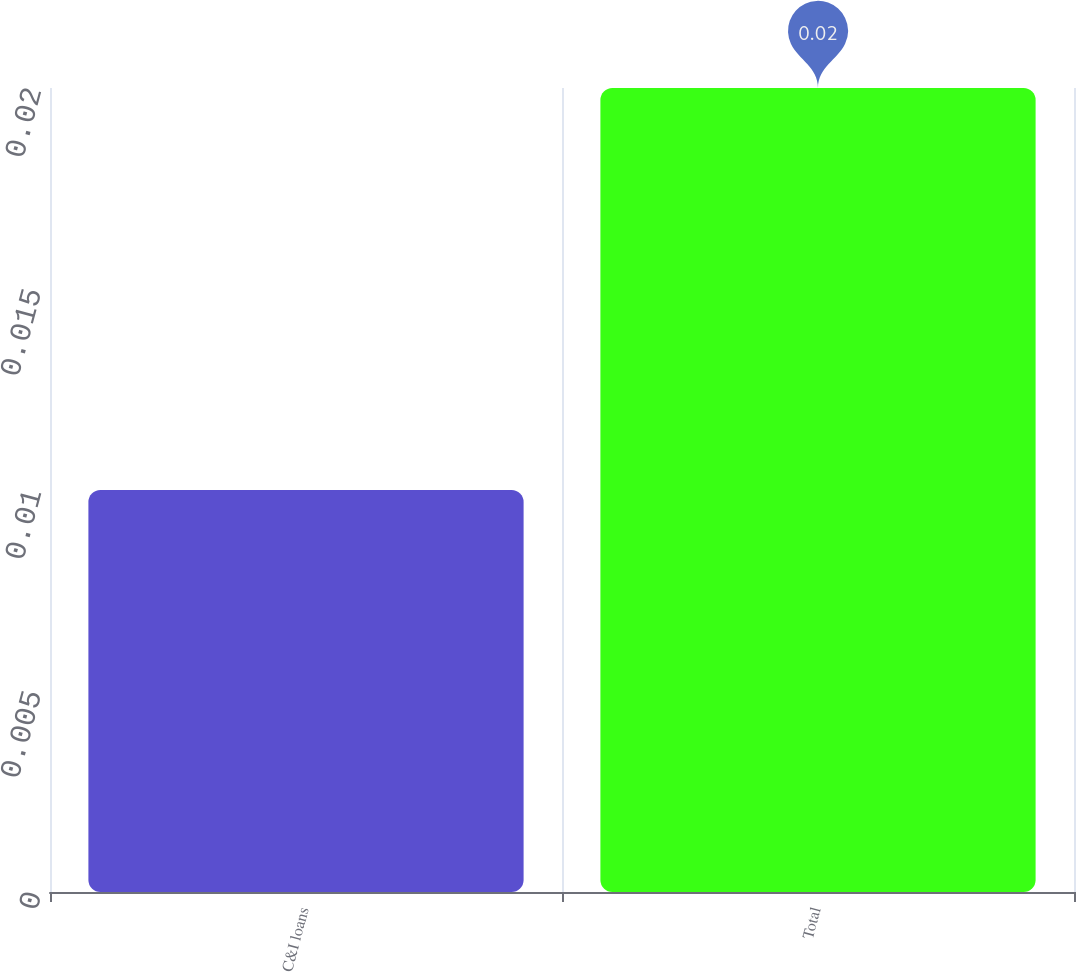Convert chart. <chart><loc_0><loc_0><loc_500><loc_500><bar_chart><fcel>C&I loans<fcel>Total<nl><fcel>0.01<fcel>0.02<nl></chart> 